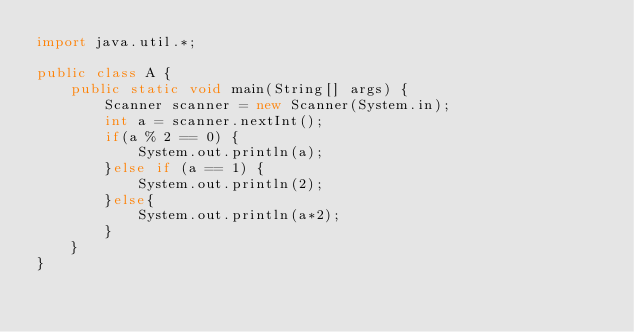<code> <loc_0><loc_0><loc_500><loc_500><_Java_>import java.util.*;

public class A {
	public static void main(String[] args) {
		Scanner scanner = new Scanner(System.in);
		int a = scanner.nextInt();
		if(a % 2 == 0) {
			System.out.println(a);
		}else if (a == 1) {
			System.out.println(2);
		}else{
			System.out.println(a*2);
		}
	}
}
</code> 